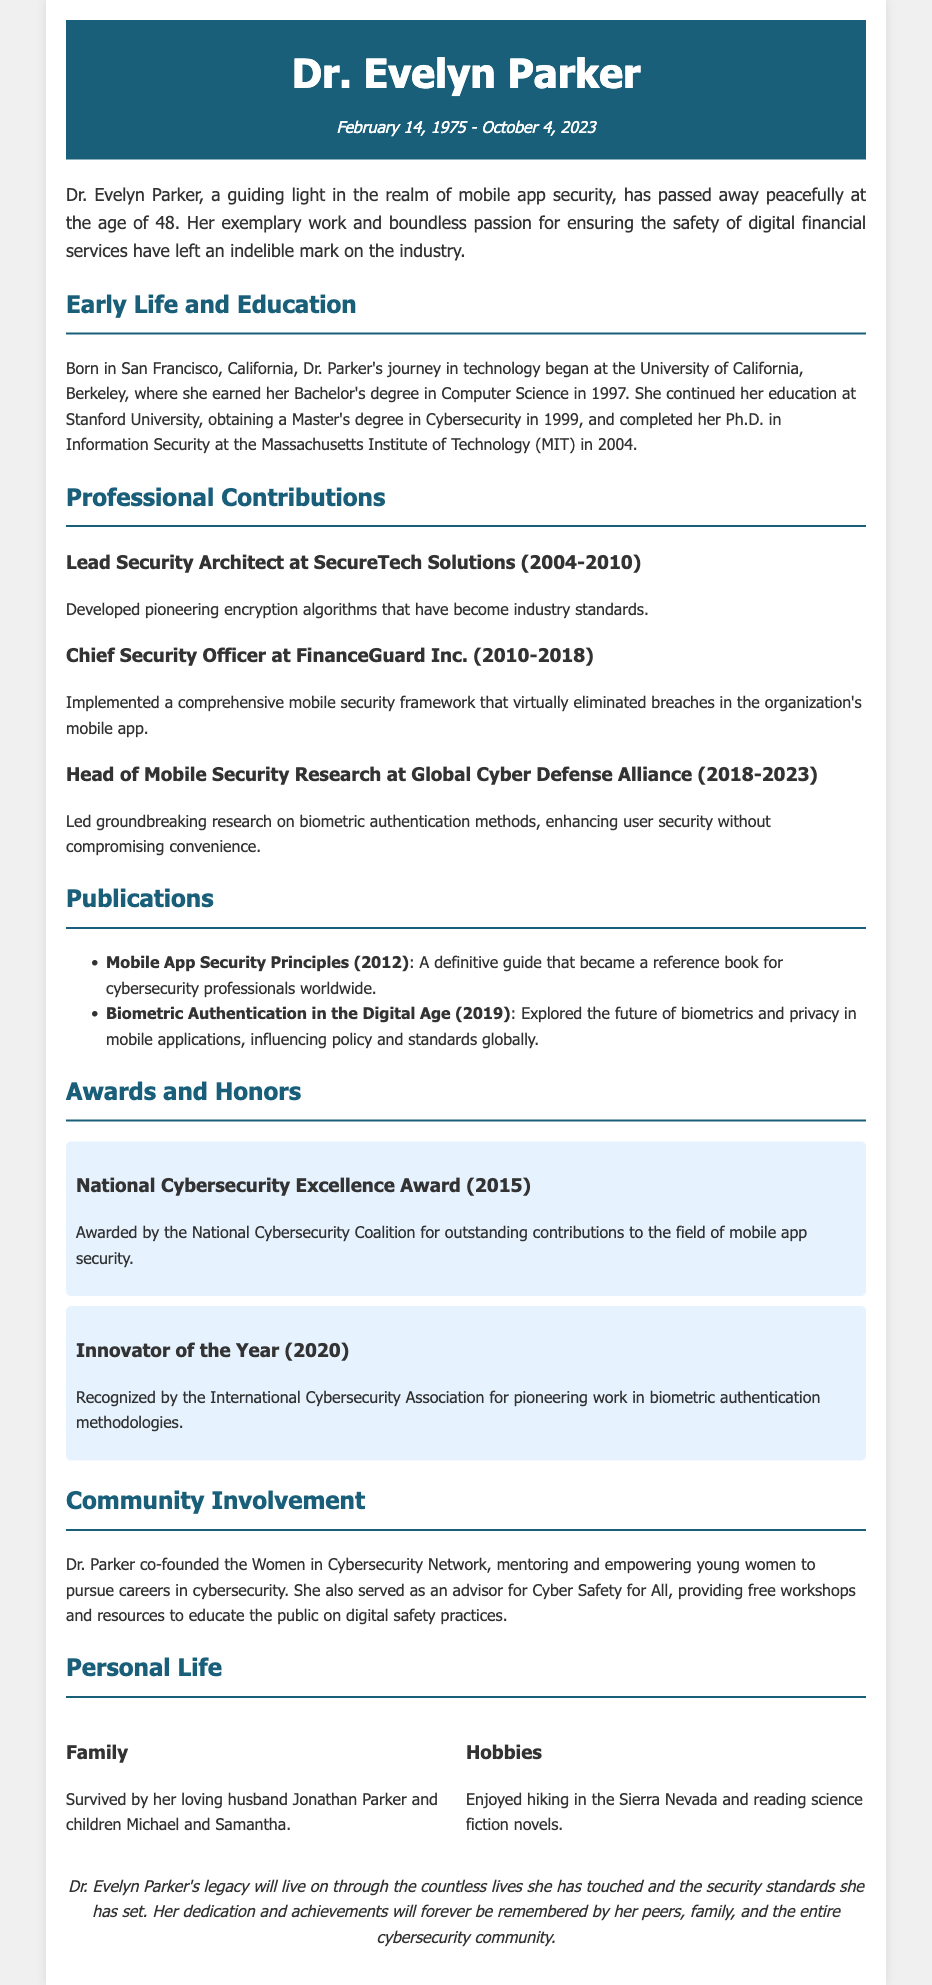What was Dr. Parker's role at SecureTech Solutions? Dr. Parker served as the Lead Security Architect at SecureTech Solutions from 2004 to 2010, where she developed pioneering encryption algorithms.
Answer: Lead Security Architect What year did Dr. Parker obtain her Ph.D.? The document states that Dr. Parker completed her Ph.D. in Information Security at MIT in 2004.
Answer: 2004 Which award did Dr. Parker receive in 2015? The document mentions that Dr. Parker was awarded the National Cybersecurity Excellence Award in 2015 for her contributions to mobile app security.
Answer: National Cybersecurity Excellence Award What is one of Dr. Parker's hobbies? The document states that she enjoyed hiking in the Sierra Nevada.
Answer: Hiking How many children did Dr. Parker have? The document mentions that Dr. Parker is survived by her children, Michael and Samantha, indicating she had two children.
Answer: Two What organization did Dr. Parker co-found? The document notes that Dr. Parker co-founded the Women in Cybersecurity Network, which supports young women in the field.
Answer: Women in Cybersecurity Network What was a significant impact of Dr. Parker's work at FinanceGuard Inc.? The document highlights that Dr. Parker implemented a mobile security framework that virtually eliminated breaches in the organization's mobile app.
Answer: Eliminated breaches What was the title of Dr. Parker's publication in 2012? The document states that she published "Mobile App Security Principles" in 2012, which became a reference for cybersecurity professionals.
Answer: Mobile App Security Principles In what city was Dr. Parker born? The document indicates that Dr. Parker was born in San Francisco, California.
Answer: San Francisco 